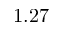<formula> <loc_0><loc_0><loc_500><loc_500>1 . 2 7</formula> 